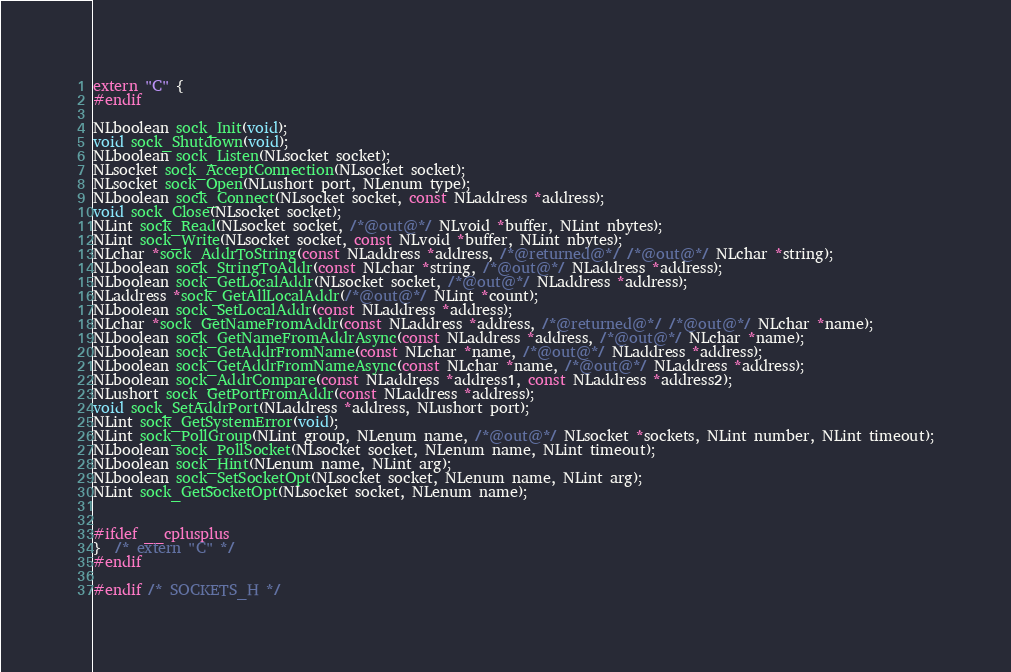<code> <loc_0><loc_0><loc_500><loc_500><_C_>extern "C" {
#endif

NLboolean sock_Init(void);
void sock_Shutdown(void);
NLboolean sock_Listen(NLsocket socket);
NLsocket sock_AcceptConnection(NLsocket socket);
NLsocket sock_Open(NLushort port, NLenum type);
NLboolean sock_Connect(NLsocket socket, const NLaddress *address);
void sock_Close(NLsocket socket);
NLint sock_Read(NLsocket socket, /*@out@*/ NLvoid *buffer, NLint nbytes);
NLint sock_Write(NLsocket socket, const NLvoid *buffer, NLint nbytes);
NLchar *sock_AddrToString(const NLaddress *address, /*@returned@*/ /*@out@*/ NLchar *string);
NLboolean sock_StringToAddr(const NLchar *string, /*@out@*/ NLaddress *address);
NLboolean sock_GetLocalAddr(NLsocket socket, /*@out@*/ NLaddress *address);
NLaddress *sock_GetAllLocalAddr(/*@out@*/ NLint *count);
NLboolean sock_SetLocalAddr(const NLaddress *address);
NLchar *sock_GetNameFromAddr(const NLaddress *address, /*@returned@*/ /*@out@*/ NLchar *name);
NLboolean sock_GetNameFromAddrAsync(const NLaddress *address, /*@out@*/ NLchar *name);
NLboolean sock_GetAddrFromName(const NLchar *name, /*@out@*/ NLaddress *address);
NLboolean sock_GetAddrFromNameAsync(const NLchar *name, /*@out@*/ NLaddress *address);
NLboolean sock_AddrCompare(const NLaddress *address1, const NLaddress *address2);
NLushort sock_GetPortFromAddr(const NLaddress *address);
void sock_SetAddrPort(NLaddress *address, NLushort port);
NLint sock_GetSystemError(void);
NLint sock_PollGroup(NLint group, NLenum name, /*@out@*/ NLsocket *sockets, NLint number, NLint timeout);
NLboolean sock_PollSocket(NLsocket socket, NLenum name, NLint timeout);
NLboolean sock_Hint(NLenum name, NLint arg);
NLboolean sock_SetSocketOpt(NLsocket socket, NLenum name, NLint arg);
NLint sock_GetSocketOpt(NLsocket socket, NLenum name);


#ifdef __cplusplus
}  /* extern "C" */
#endif

#endif /* SOCKETS_H */

</code> 